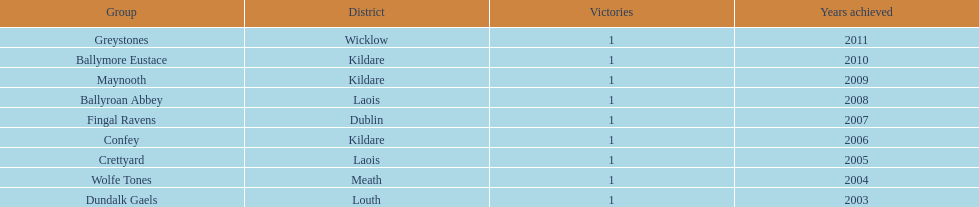How many wins did confey have? 1. 